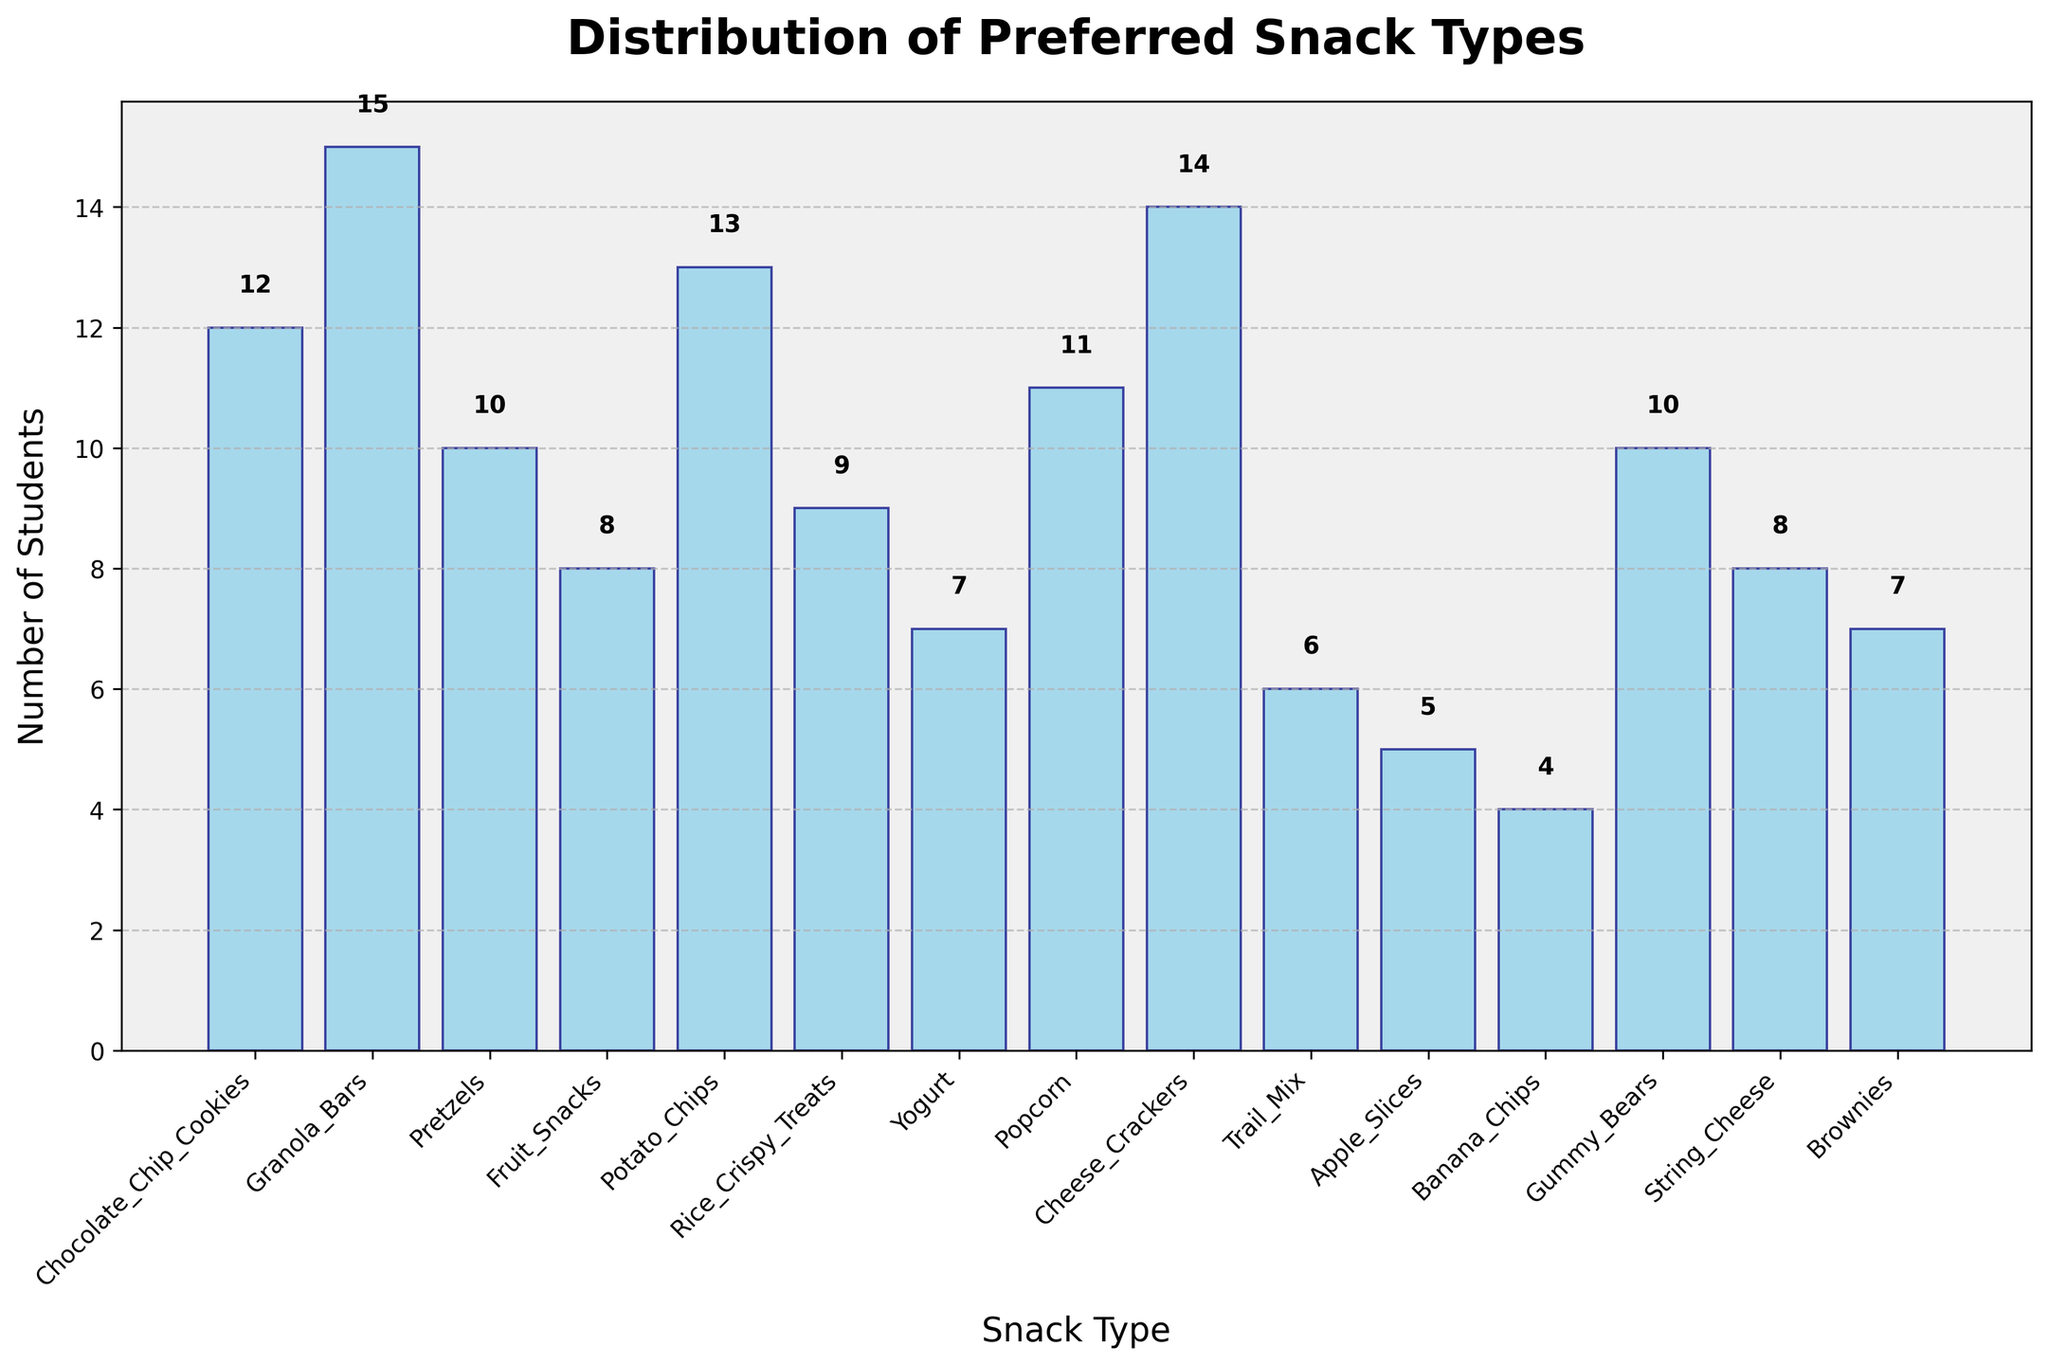What is the title of the plot? The title of the plot is displayed at the top of the figure. It reads 'Distribution of Preferred Snack Types'.
Answer: Distribution of Preferred Snack Types Which snack is preferred by the highest number of students? By looking at the bar that reaches the highest point on the y-axis, we can see that 'Granola Bars' is the most preferred snack with 15 students choosing it.
Answer: Granola Bars How many students prefer 'Rice Crispy Treats'? We can see the height of the bar labeled 'Rice Crispy Treats'. There's also a value label on top of the bar showing 9 students.
Answer: 9 What is the total number of students who prefer 'Apple Slices' and 'Banana Chips'? We need to find the values for both 'Apple Slices' (5) and 'Banana Chips' (4), and then sum these values: 5 + 4 = 9.
Answer: 9 Which snack type is preferred by exactly 10 students? By checking the bar heights and the value labels on top, we see that both 'Pretzels' and 'Gummy Bears' are preferred by exactly 10 students.
Answer: Pretzels, Gummy Bears What is the combined number of students who prefer 'Chocolate Chip Cookies' and 'Potato Chips'? Adding the values for 'Chocolate Chip Cookies' (12) and 'Potato Chips' (13): 12 + 13 = 25.
Answer: 25 How many snack types are preferred by fewer than 10 students? Counting the bars with height less than 10, we include 'Rice Crispy Treats' (9), 'Yogurt' (7), 'Trail Mix' (6), 'Apple Slices' (5), 'Banana Chips' (4), and 'String Cheese' (8). There are 6 snack types.
Answer: 6 Are there more students who prefer 'Cheese Crackers' or 'Popcorn'? Comparing the values of 'Cheese Crackers' (14) and 'Popcorn' (11), we can see that more students prefer 'Cheese Crackers'.
Answer: Cheese Crackers What is the average number of students per snack type? To calculate the average, sum up all the student counts and divide by the number of snack types: (12+15+10+8+13+9+7+11+14+6+5+4+10+8+7) = 139, and there are 15 snack types. So, the average is 139/15 ≈ 9.27.
Answer: 9.27 Which snack type has the closest number of student preferences to the median value? To find the median, we need to order the student counts and find the middle value. Ordered counts: [4, 5, 6, 7, 7, 8, 8, 9, 10, 10, 11, 12, 13, 14, 15]. The median value is 9. Observing the bar with this value, 'Rice Crispy Treats' has exactly 9 students.
Answer: Rice Crispy Treats 